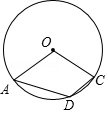Can you explain what an inscribed angle in a circle means and why it's significant in this context? An inscribed angle is formed by two chords in a circle that intersect at a point on the circle. It's significant here because the measure of an inscribed angle is always half the measure of the central angle that subtends (intercepts) the same arc on the circle. This is a key theorem in circle geometry and is directly relevant to finding the measure of angle ADC in the given diagram. 